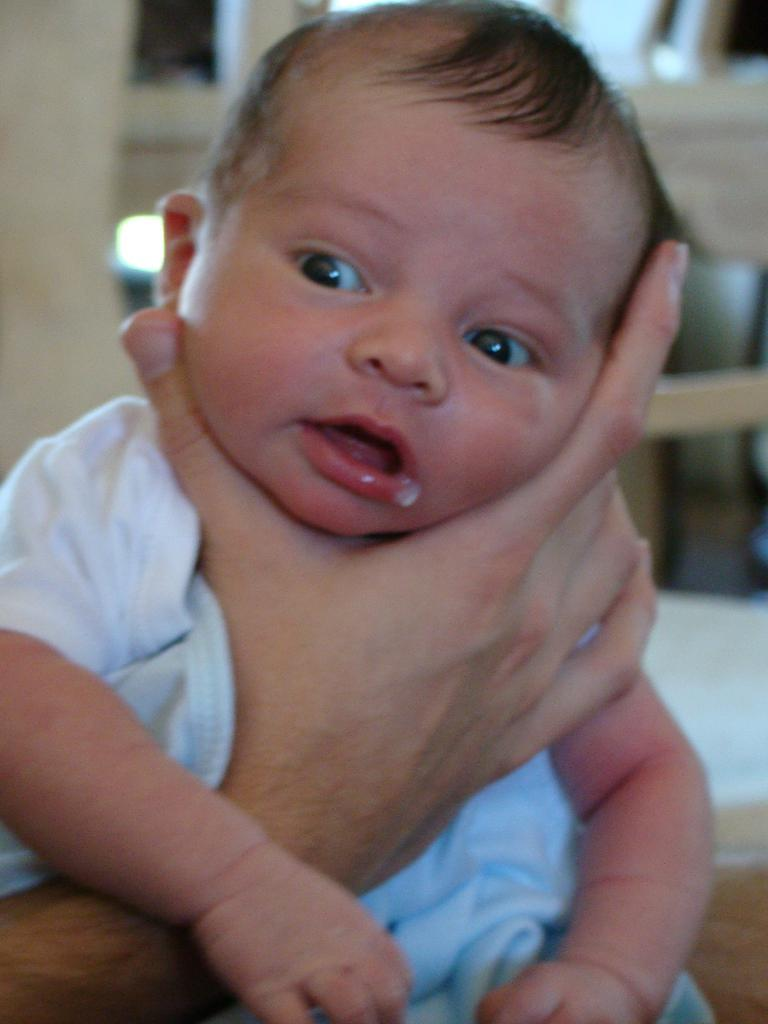What is the main subject of the image? There is a baby in the image. How is the baby being held in the image? The baby is being held by a human hand. What can be seen in the background of the image? There are wooden sticks in the background of the image. What type of surface is visible in the image? There is a floor visible in the image. What year is depicted in the image? The image does not depict a specific year; it is a photograph of a baby being held by a hand. What is the baby's father doing in the image? There is no information about the baby's father in the image; only a hand is visible holding the baby. 